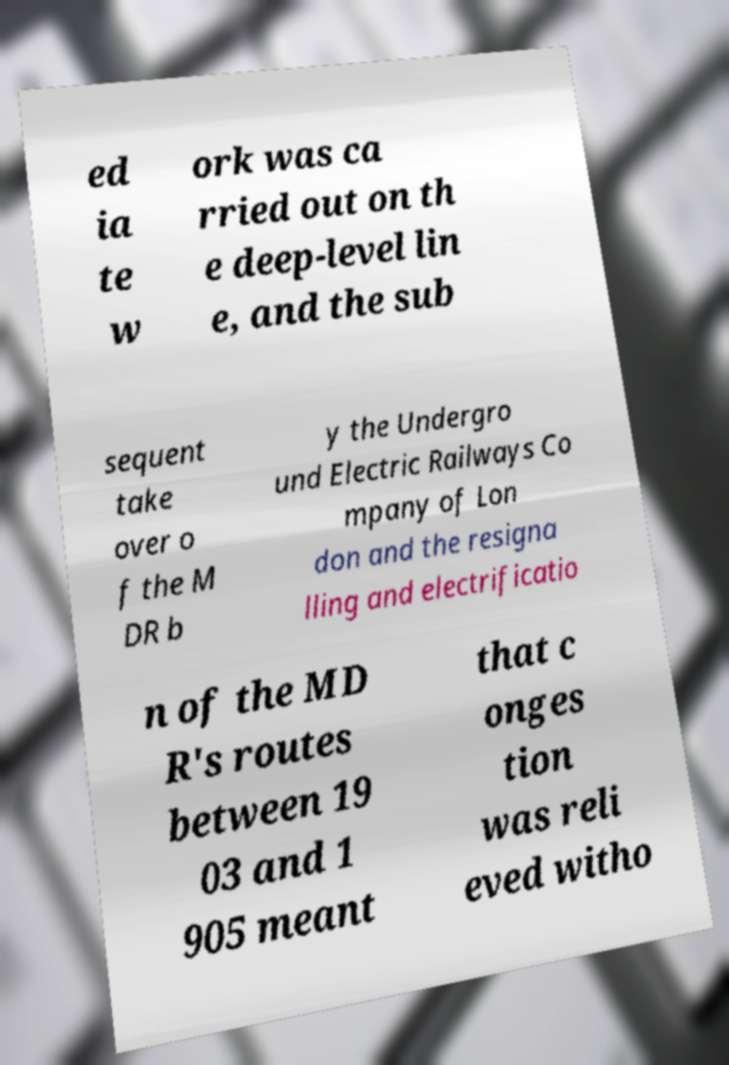Can you accurately transcribe the text from the provided image for me? ed ia te w ork was ca rried out on th e deep-level lin e, and the sub sequent take over o f the M DR b y the Undergro und Electric Railways Co mpany of Lon don and the resigna lling and electrificatio n of the MD R's routes between 19 03 and 1 905 meant that c onges tion was reli eved witho 